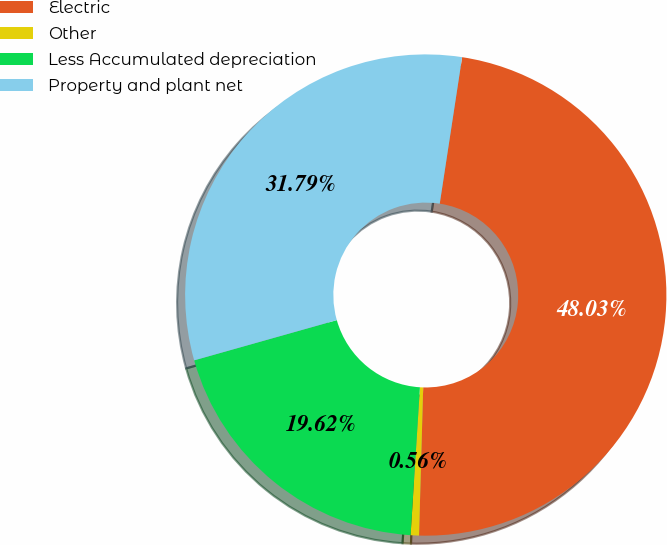Convert chart to OTSL. <chart><loc_0><loc_0><loc_500><loc_500><pie_chart><fcel>Electric<fcel>Other<fcel>Less Accumulated depreciation<fcel>Property and plant net<nl><fcel>48.03%<fcel>0.56%<fcel>19.62%<fcel>31.79%<nl></chart> 